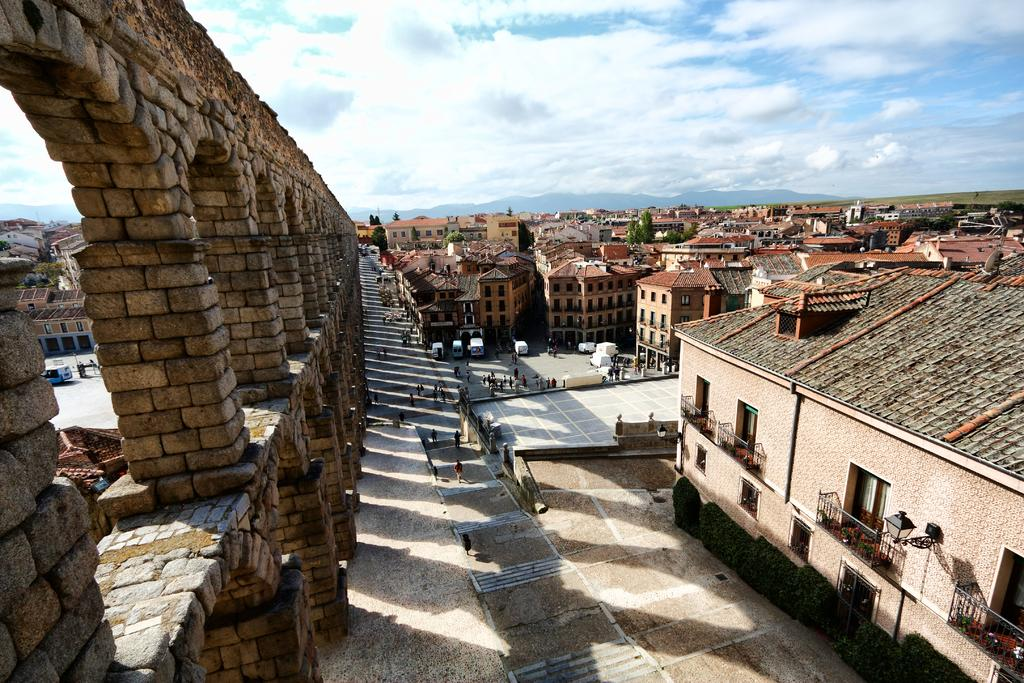What can be seen in the foreground of the image? There are buildings, trees, and people on the ground in the foreground of the image. What is visible in the background of the image? The sky is visible in the image. What can be observed in the sky? There are clouds in the sky. What is located on the left side of the image? There is a wall on the left side of the image. What type of treatment is being administered to the trees in the image? There is no treatment being administered to the trees in the image; they are simply standing in the foreground. What print can be seen on the wall on the left side of the image? There is no print visible on the wall in the image; it is a plain wall. 